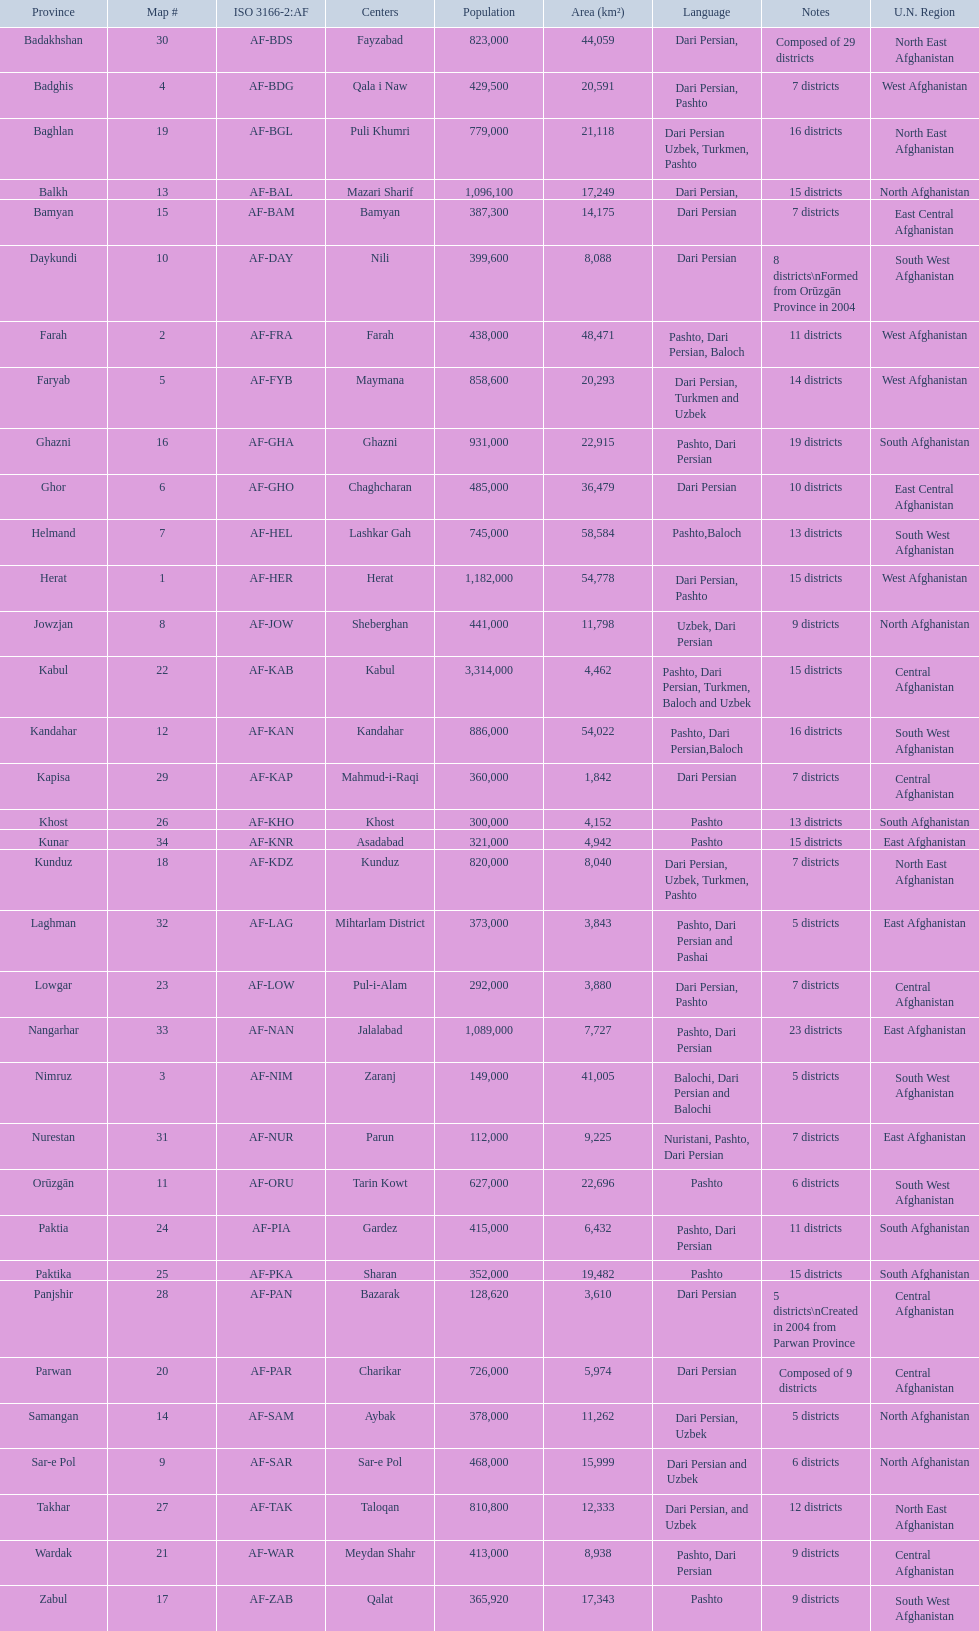In which provinces can pashto be found as a spoken language? 20. I'm looking to parse the entire table for insights. Could you assist me with that? {'header': ['Province', 'Map #', 'ISO 3166-2:AF', 'Centers', 'Population', 'Area (km²)', 'Language', 'Notes', 'U.N. Region'], 'rows': [['Badakhshan', '30', 'AF-BDS', 'Fayzabad', '823,000', '44,059', 'Dari Persian,', 'Composed of 29 districts', 'North East Afghanistan'], ['Badghis', '4', 'AF-BDG', 'Qala i Naw', '429,500', '20,591', 'Dari Persian, Pashto', '7 districts', 'West Afghanistan'], ['Baghlan', '19', 'AF-BGL', 'Puli Khumri', '779,000', '21,118', 'Dari Persian Uzbek, Turkmen, Pashto', '16 districts', 'North East Afghanistan'], ['Balkh', '13', 'AF-BAL', 'Mazari Sharif', '1,096,100', '17,249', 'Dari Persian,', '15 districts', 'North Afghanistan'], ['Bamyan', '15', 'AF-BAM', 'Bamyan', '387,300', '14,175', 'Dari Persian', '7 districts', 'East Central Afghanistan'], ['Daykundi', '10', 'AF-DAY', 'Nili', '399,600', '8,088', 'Dari Persian', '8 districts\\nFormed from Orūzgān Province in 2004', 'South West Afghanistan'], ['Farah', '2', 'AF-FRA', 'Farah', '438,000', '48,471', 'Pashto, Dari Persian, Baloch', '11 districts', 'West Afghanistan'], ['Faryab', '5', 'AF-FYB', 'Maymana', '858,600', '20,293', 'Dari Persian, Turkmen and Uzbek', '14 districts', 'West Afghanistan'], ['Ghazni', '16', 'AF-GHA', 'Ghazni', '931,000', '22,915', 'Pashto, Dari Persian', '19 districts', 'South Afghanistan'], ['Ghor', '6', 'AF-GHO', 'Chaghcharan', '485,000', '36,479', 'Dari Persian', '10 districts', 'East Central Afghanistan'], ['Helmand', '7', 'AF-HEL', 'Lashkar Gah', '745,000', '58,584', 'Pashto,Baloch', '13 districts', 'South West Afghanistan'], ['Herat', '1', 'AF-HER', 'Herat', '1,182,000', '54,778', 'Dari Persian, Pashto', '15 districts', 'West Afghanistan'], ['Jowzjan', '8', 'AF-JOW', 'Sheberghan', '441,000', '11,798', 'Uzbek, Dari Persian', '9 districts', 'North Afghanistan'], ['Kabul', '22', 'AF-KAB', 'Kabul', '3,314,000', '4,462', 'Pashto, Dari Persian, Turkmen, Baloch and Uzbek', '15 districts', 'Central Afghanistan'], ['Kandahar', '12', 'AF-KAN', 'Kandahar', '886,000', '54,022', 'Pashto, Dari Persian,Baloch', '16 districts', 'South West Afghanistan'], ['Kapisa', '29', 'AF-KAP', 'Mahmud-i-Raqi', '360,000', '1,842', 'Dari Persian', '7 districts', 'Central Afghanistan'], ['Khost', '26', 'AF-KHO', 'Khost', '300,000', '4,152', 'Pashto', '13 districts', 'South Afghanistan'], ['Kunar', '34', 'AF-KNR', 'Asadabad', '321,000', '4,942', 'Pashto', '15 districts', 'East Afghanistan'], ['Kunduz', '18', 'AF-KDZ', 'Kunduz', '820,000', '8,040', 'Dari Persian, Uzbek, Turkmen, Pashto', '7 districts', 'North East Afghanistan'], ['Laghman', '32', 'AF-LAG', 'Mihtarlam District', '373,000', '3,843', 'Pashto, Dari Persian and Pashai', '5 districts', 'East Afghanistan'], ['Lowgar', '23', 'AF-LOW', 'Pul-i-Alam', '292,000', '3,880', 'Dari Persian, Pashto', '7 districts', 'Central Afghanistan'], ['Nangarhar', '33', 'AF-NAN', 'Jalalabad', '1,089,000', '7,727', 'Pashto, Dari Persian', '23 districts', 'East Afghanistan'], ['Nimruz', '3', 'AF-NIM', 'Zaranj', '149,000', '41,005', 'Balochi, Dari Persian and Balochi', '5 districts', 'South West Afghanistan'], ['Nurestan', '31', 'AF-NUR', 'Parun', '112,000', '9,225', 'Nuristani, Pashto, Dari Persian', '7 districts', 'East Afghanistan'], ['Orūzgān', '11', 'AF-ORU', 'Tarin Kowt', '627,000', '22,696', 'Pashto', '6 districts', 'South West Afghanistan'], ['Paktia', '24', 'AF-PIA', 'Gardez', '415,000', '6,432', 'Pashto, Dari Persian', '11 districts', 'South Afghanistan'], ['Paktika', '25', 'AF-PKA', 'Sharan', '352,000', '19,482', 'Pashto', '15 districts', 'South Afghanistan'], ['Panjshir', '28', 'AF-PAN', 'Bazarak', '128,620', '3,610', 'Dari Persian', '5 districts\\nCreated in 2004 from Parwan Province', 'Central Afghanistan'], ['Parwan', '20', 'AF-PAR', 'Charikar', '726,000', '5,974', 'Dari Persian', 'Composed of 9 districts', 'Central Afghanistan'], ['Samangan', '14', 'AF-SAM', 'Aybak', '378,000', '11,262', 'Dari Persian, Uzbek', '5 districts', 'North Afghanistan'], ['Sar-e Pol', '9', 'AF-SAR', 'Sar-e Pol', '468,000', '15,999', 'Dari Persian and Uzbek', '6 districts', 'North Afghanistan'], ['Takhar', '27', 'AF-TAK', 'Taloqan', '810,800', '12,333', 'Dari Persian, and Uzbek', '12 districts', 'North East Afghanistan'], ['Wardak', '21', 'AF-WAR', 'Meydan Shahr', '413,000', '8,938', 'Pashto, Dari Persian', '9 districts', 'Central Afghanistan'], ['Zabul', '17', 'AF-ZAB', 'Qalat', '365,920', '17,343', 'Pashto', '9 districts', 'South West Afghanistan']]} 